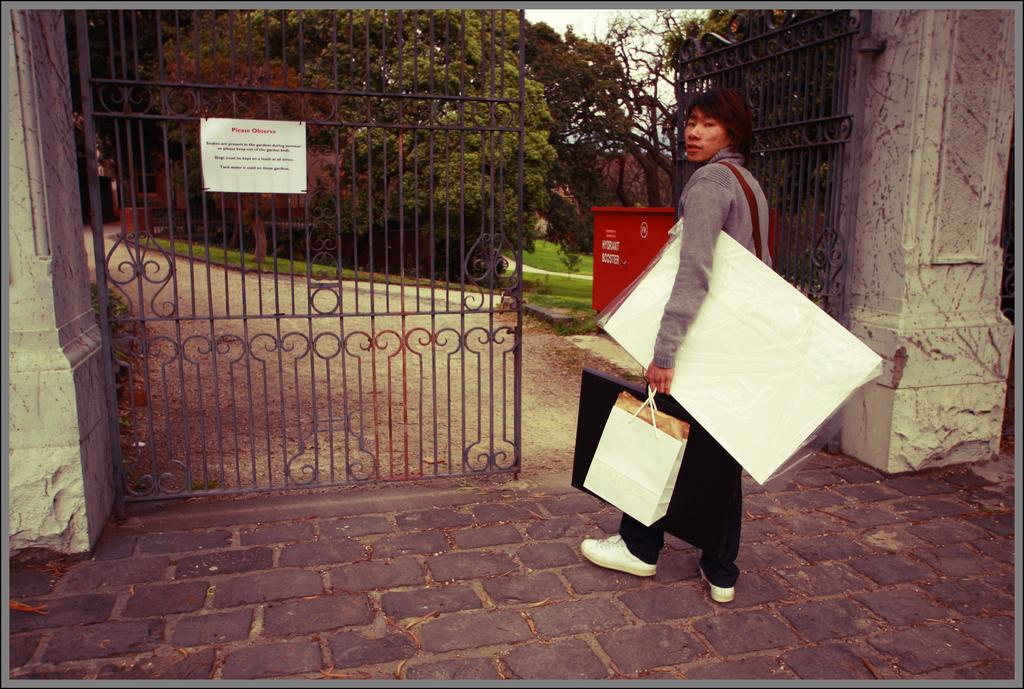What is the main subject of the image? There is a person in the image. What is the person doing in the image? The person is holding multiple objects and entering through a gate. What type of committee can be seen in the image? There is no committee present in the image; it features a person holding multiple objects and entering through a gate. What is the person using to slow down their movement in the image? There is no indication of the person slowing down or using a brake in the image. 